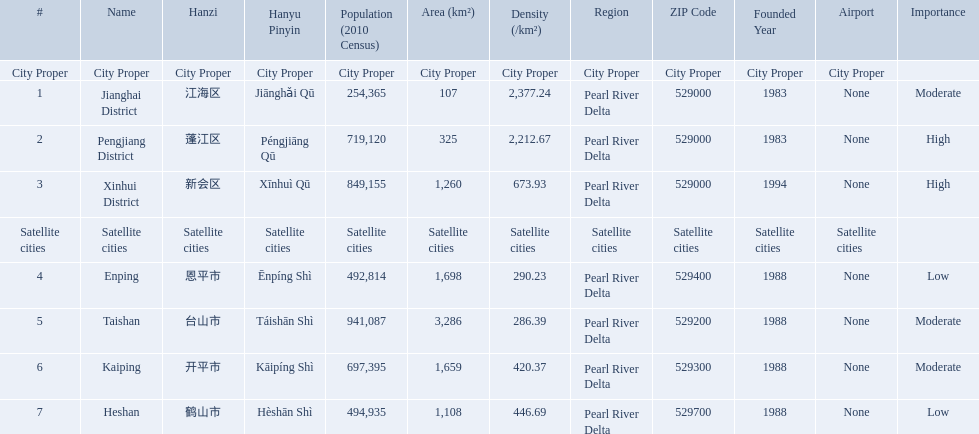What are the satellite cities of jiangmen? Enping, Taishan, Kaiping, Heshan. Of these cities, which has the highest density? Taishan. What are all the cities? Jianghai District, Pengjiang District, Xinhui District, Enping, Taishan, Kaiping, Heshan. Of these, which are satellite cities? Enping, Taishan, Kaiping, Heshan. For these, what are their populations? 492,814, 941,087, 697,395, 494,935. Of these, which is the largest? 941,087. Which city has this population? Taishan. What are all of the city proper district names? Jianghai District, Pengjiang District, Xinhui District. Of those districts, what are is the value for their area (km2)? 107, 325, 1,260. Of those area values, which district does the smallest value belong to? Jianghai District. 